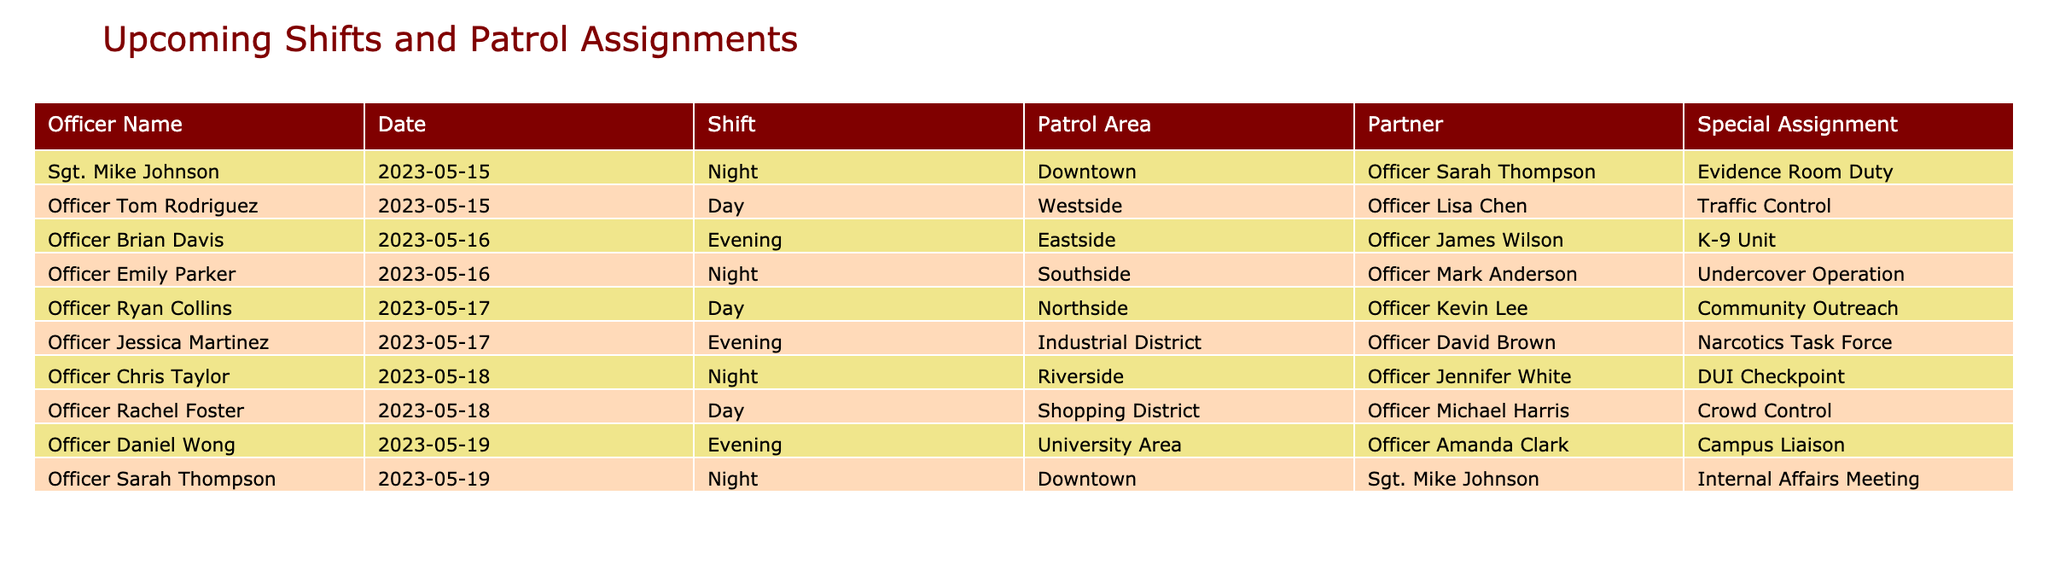What shift is Officer Tom Rodriguez working on May 15, 2023? Looking at the table, Officer Tom Rodriguez has a listed shift of Day on May 15, 2023.
Answer: Day How many officers are scheduled for the Night shift on May 19, 2023? On May 19, 2023, one officer, Sgt. Mike Johnson, is scheduled for the Night shift according to the table.
Answer: 1 Which patrol area is Officer Jessica Martinez assigned to on May 17, 2023? The table shows that Officer Jessica Martinez is assigned to the Industrial District on May 17, 2023.
Answer: Industrial District Is there a special assignment for Officer Chris Taylor? The table indicates that Officer Chris Taylor has a special assignment of DUI Checkpoint on his scheduled Night shift.
Answer: Yes What is the total number of officers scheduled for Day shifts over the dates provided? By reviewing the shifts in the table, there are three officers assigned to Day shifts across the dates: Officer Tom Rodriguez, Officer Ryan Collins, and Officer Rachel Foster.
Answer: 3 Which officer is partnered with Officer Emily Parker during her Night shift? According to the table, Officer Emily Parker is partnered with Officer Mark Anderson on her Night shift.
Answer: Officer Mark Anderson How many officers are assigned to the Downtown patrol area across all shifts? The table shows that there are two entries for the Downtown patrol area, one for Sgt. Mike Johnson and another for Officer Sarah Thompson, indicating they are assigned here.
Answer: 2 What is the special assignment for Officer Sarah Thompson on her Night shift? The table indicates that Officer Sarah Thompson has an assignment during the Night shift for an Internal Affairs Meeting.
Answer: Internal Affairs Meeting Which officer is on the K-9 Unit assignment and when are they scheduled? Officer Brian Davis is scheduled for the Evening shift on May 16, 2023, with the K-9 Unit assignment, as shown in the table.
Answer: Officer Brian Davis, May 16, 2023 